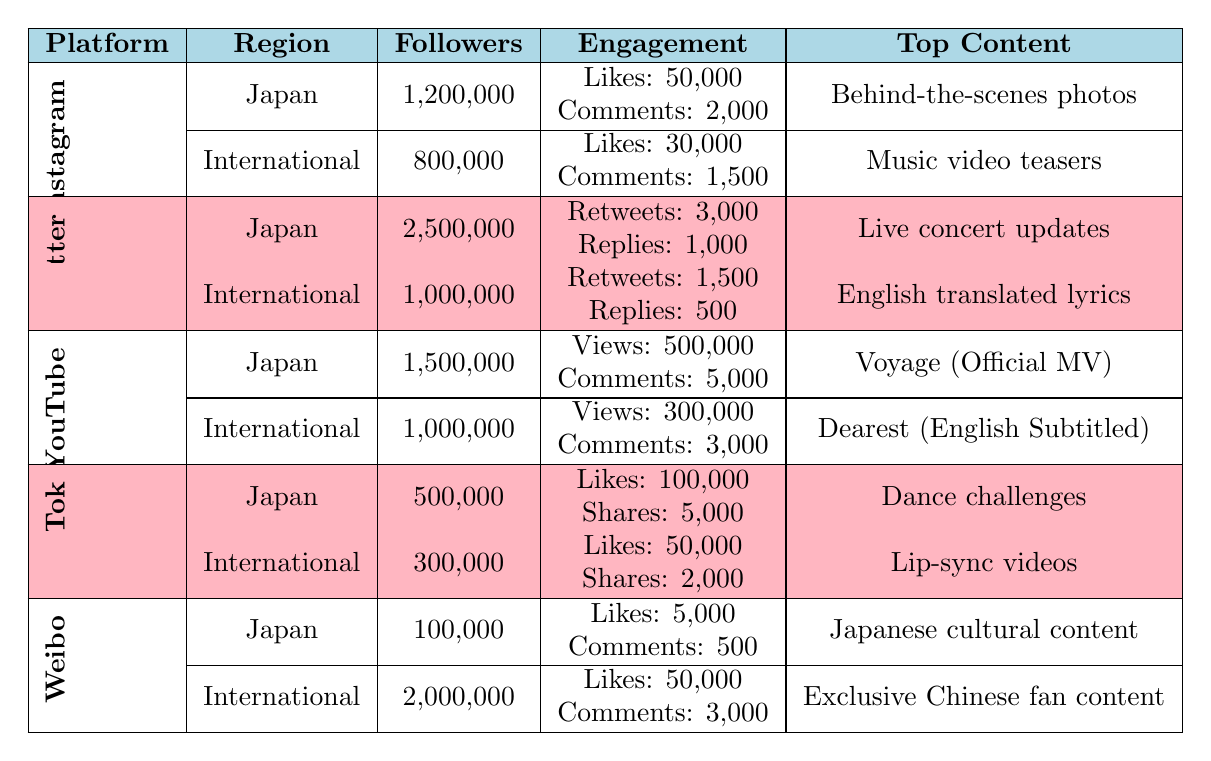What is the total number of followers Ayumi Hamasaki has on Twitter in Japan? The table indicates that Ayumi has 2,500,000 followers on Twitter in Japan.
Answer: 2,500,000 Which platform has the most engagement in Japan based on average likes? On Instagram, the average likes in Japan are 50,000, while on TikTok, it is 100,000. However, since average likes were considered, TikTok has more average likes (100,000).
Answer: TikTok What is the average number of average comments on Instagram for both Japan and International? The average comments on Instagram in Japan are 2,000, and in International, it is 1,500. Adding these gives 2,000 + 1,500 = 3,500, and dividing by 2 gives 3,500 / 2 = 1,750.
Answer: 1,750 Does Ayumi have more followers on YouTube in Japan or Internationally? Ayumi has 1,500,000 subscribers on YouTube in Japan and 1,000,000 subscribers internationally; therefore, she has more in Japan.
Answer: Yes What is the combined total of followers across all platforms in Japan? Summing the followers in Japan gives: 1,200,000 (Instagram) + 2,500,000 (Twitter) + 1,500,000 (YouTube) + 500,000 (TikTok) + 100,000 (Weibo) = 5,800,000.
Answer: 5,800,000 What are the average likes on TikTok for the international audience compared to Japan? For TikTok, the average likes are 50,000 in the international section and 100,000 in Japan. Japan has more average likes than the international audience.
Answer: Yes, Japan has more likes Which platform has the least number of followers in Japan? The table shows that YouTube has 1,500,000, Twitter has 2,500,000, Instagram has 1,200,000, TikTok has 500,000, and Weibo has 100,000. Thus, Weibo has the least followers in Japan.
Answer: Weibo What is the difference in average comments between the international Instagram and Twitter? The average comments for Instagram internationally are 1,500 and for Twitter, they are 500. The difference is 1,500 - 500 = 1,000.
Answer: 1,000 Which platform's most engaging content differs between Japan and International the most? Comparing the most engaging content, Weibo has "Japanese cultural content" in Japan while "Exclusive Chinese fan content" internationally. This shows a significant shift in engagement strategy.
Answer: Weibo How many average shares are there on TikTok internationally compared to Japan? The average shares on TikTok are 2,000 internationally and 5,000 in Japan. Therefore, Japan has more average shares.
Answer: Yes, Japan has more shares 